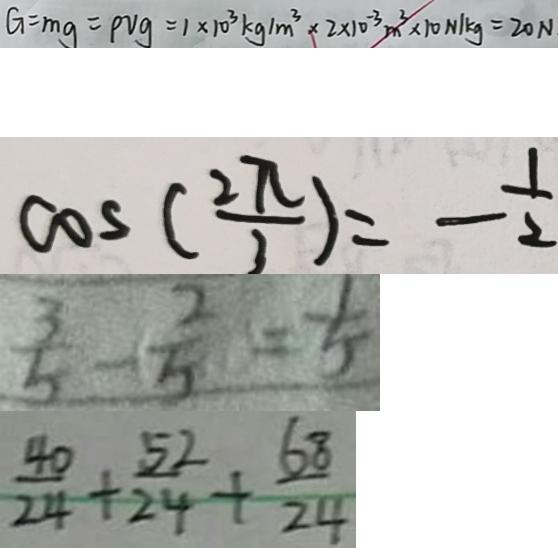Convert formula to latex. <formula><loc_0><loc_0><loc_500><loc_500>G = m g = \rho v g = 1 \times 1 0 ^ { 3 } k g / m ^ { 3 } \times 2 \times 1 0 ^ { - 3 } m ^ { 3 } \times 1 0 N / k g = 2 0 N 
 \cos ( \frac { 2 \pi } { 3 } ) = - \frac { 1 } { 2 } 
 \frac { 3 } { 5 } - \frac { 2 } { 5 } = \frac { 1 } { 5 } 
 \frac { 4 0 } { 2 4 } + \frac { 5 2 } { 2 4 } + \frac { 6 8 } { 2 4 }</formula> 